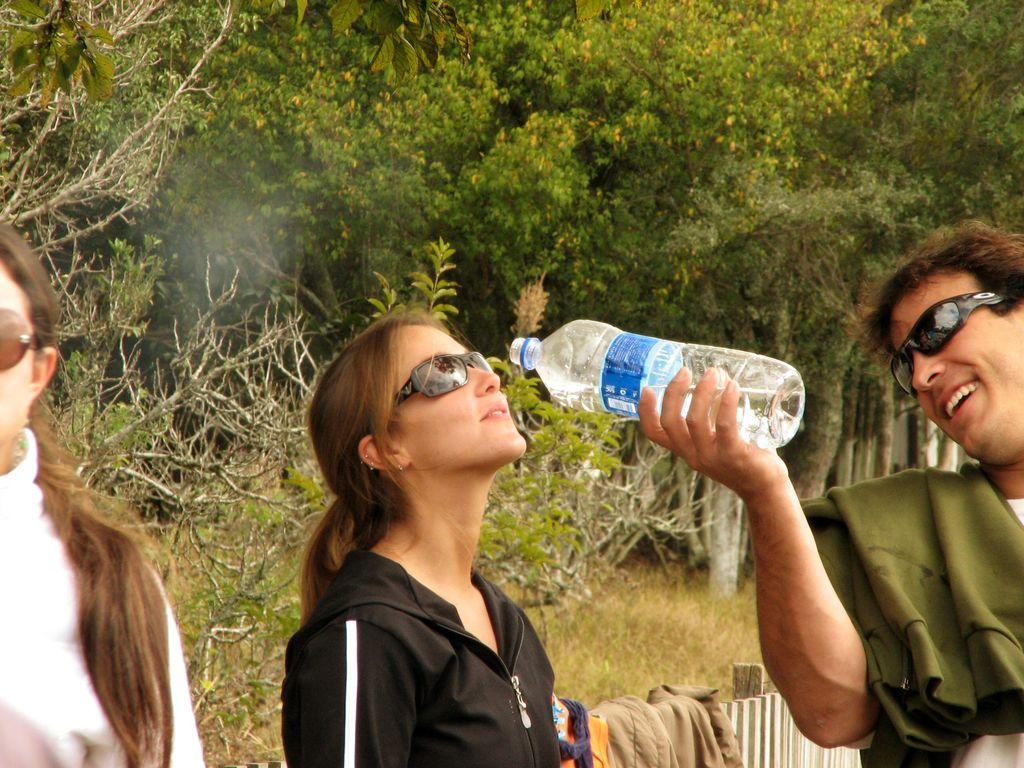How many people are in the image? There are 2 women and a man in the image. What is the man holding in the image? The man is holding a water bottle. What is the facial expression of the man in the image? The man is smiling. What can be seen in the background of the image? There are trees and plants in the background of the image. What is the chin of the man in the image made of? The image does not provide information about the man's chin, so it cannot be determined what it is made of. 